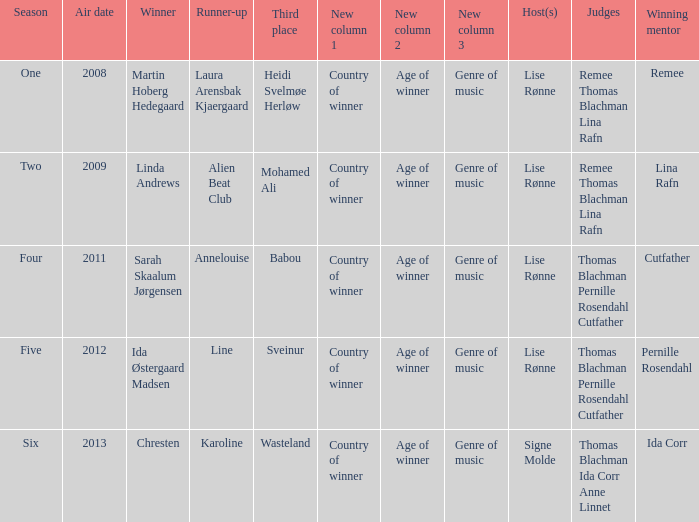Who was the runner-up when Mohamed Ali got third? Alien Beat Club. 